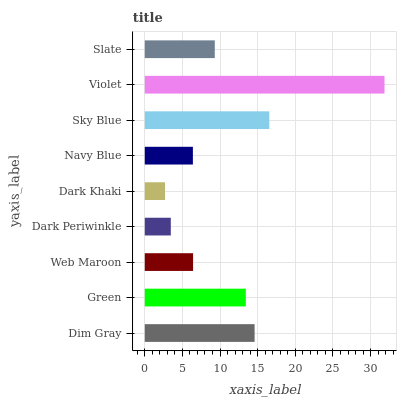Is Dark Khaki the minimum?
Answer yes or no. Yes. Is Violet the maximum?
Answer yes or no. Yes. Is Green the minimum?
Answer yes or no. No. Is Green the maximum?
Answer yes or no. No. Is Dim Gray greater than Green?
Answer yes or no. Yes. Is Green less than Dim Gray?
Answer yes or no. Yes. Is Green greater than Dim Gray?
Answer yes or no. No. Is Dim Gray less than Green?
Answer yes or no. No. Is Slate the high median?
Answer yes or no. Yes. Is Slate the low median?
Answer yes or no. Yes. Is Dark Periwinkle the high median?
Answer yes or no. No. Is Dim Gray the low median?
Answer yes or no. No. 